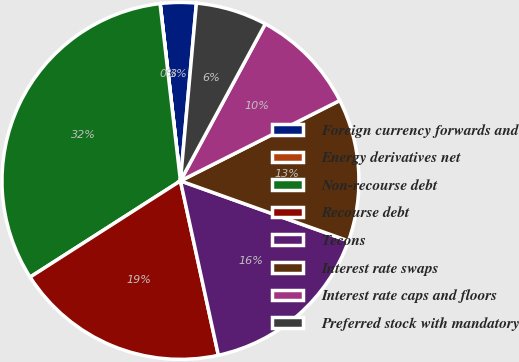Convert chart. <chart><loc_0><loc_0><loc_500><loc_500><pie_chart><fcel>Foreign currency forwards and<fcel>Energy derivatives net<fcel>Non-recourse debt<fcel>Recourse debt<fcel>Tecons<fcel>Interest rate swaps<fcel>Interest rate caps and floors<fcel>Preferred stock with mandatory<nl><fcel>3.24%<fcel>0.01%<fcel>32.24%<fcel>19.35%<fcel>16.13%<fcel>12.9%<fcel>9.68%<fcel>6.46%<nl></chart> 